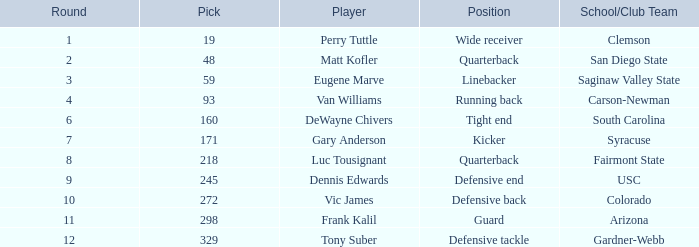In which round does a school or club team from arizona participate with a pick number less than 298? None. 